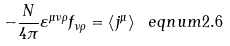Convert formula to latex. <formula><loc_0><loc_0><loc_500><loc_500>- \frac { N } { 4 \pi } \varepsilon ^ { \mu \nu \rho } f _ { \nu \rho } = \left \langle j ^ { \mu } \right \rangle \ e q n u m { 2 . 6 }</formula> 